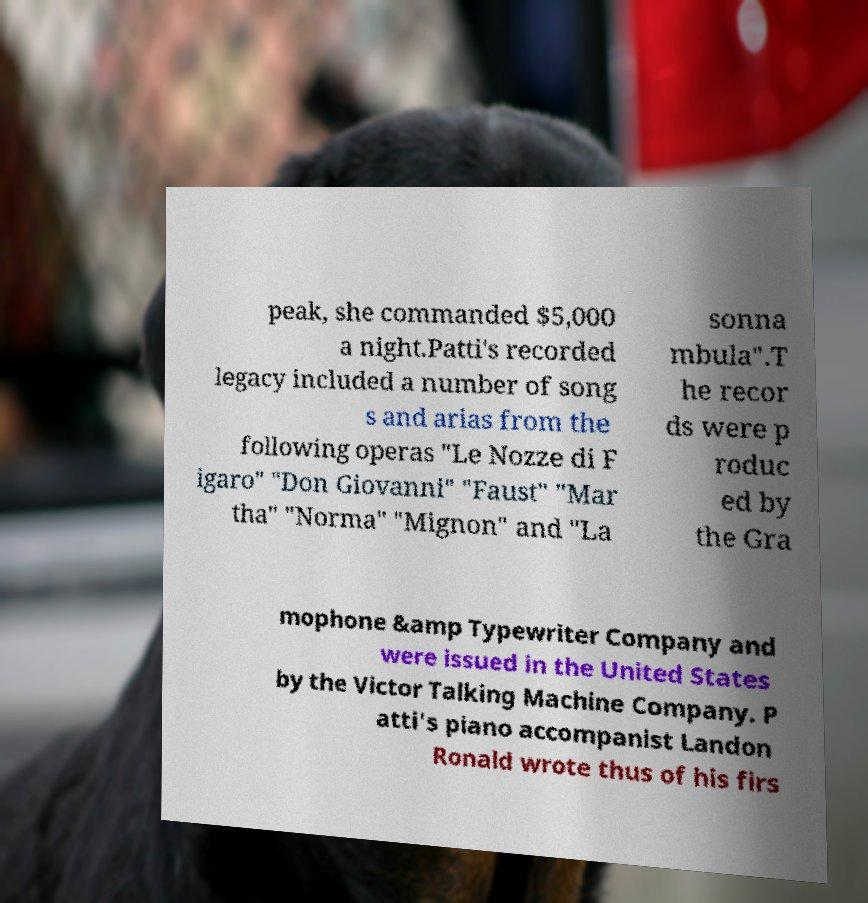Could you assist in decoding the text presented in this image and type it out clearly? peak, she commanded $5,000 a night.Patti's recorded legacy included a number of song s and arias from the following operas "Le Nozze di F igaro" "Don Giovanni" "Faust" "Mar tha" "Norma" "Mignon" and "La sonna mbula".T he recor ds were p roduc ed by the Gra mophone &amp Typewriter Company and were issued in the United States by the Victor Talking Machine Company. P atti's piano accompanist Landon Ronald wrote thus of his firs 